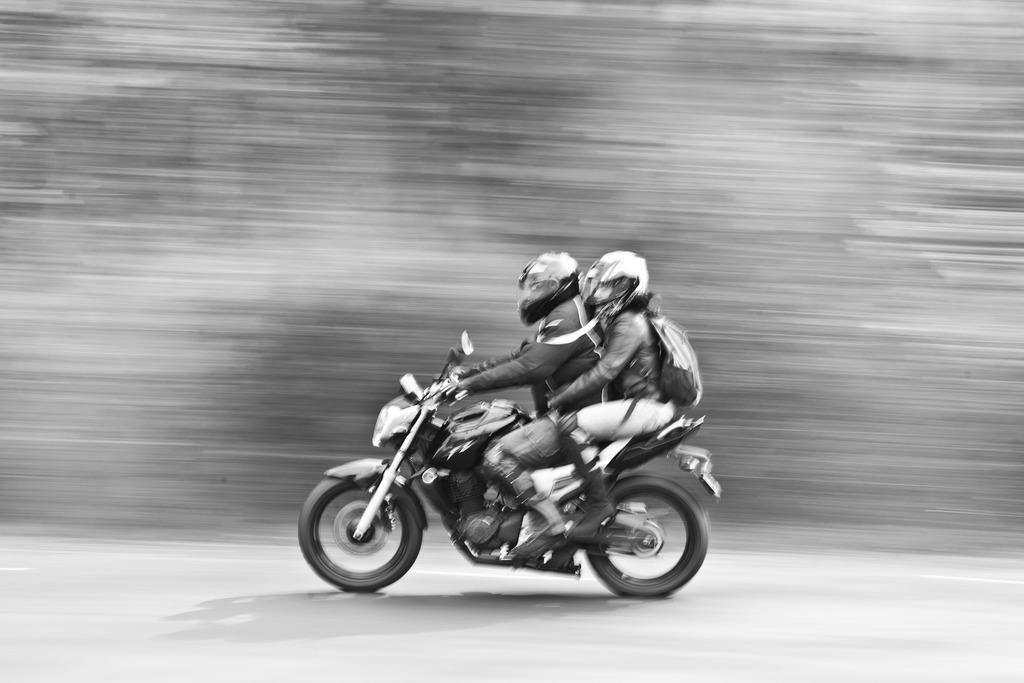What is the man in the image doing? The man is riding a motor bicycle in the image. Who is with the man on the motor bicycle? There is a woman sitting on the motor bicycle with the man. What is the woman wearing on her back? The woman is wearing a backpack on her back. What type of trousers is the man wearing in the image? The provided facts do not mention the type of trousers the man is wearing in the image. 